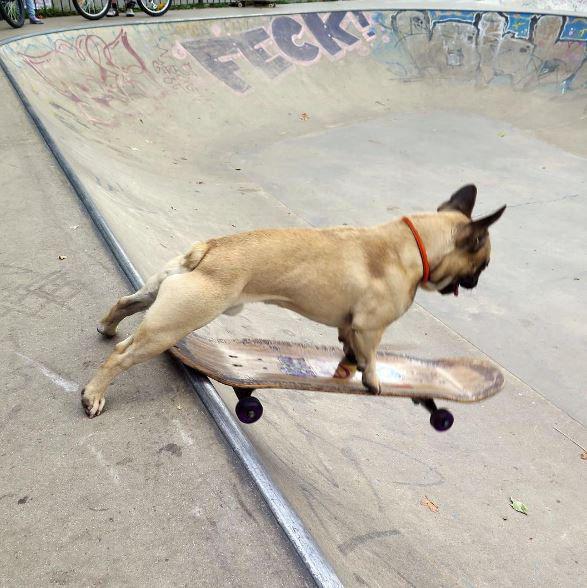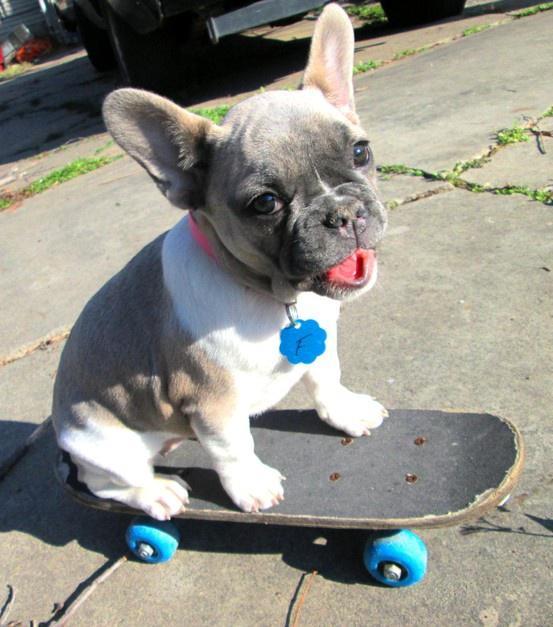The first image is the image on the left, the second image is the image on the right. For the images displayed, is the sentence "At least one image features more than one dog on a skateboard." factually correct? Answer yes or no. No. The first image is the image on the left, the second image is the image on the right. Evaluate the accuracy of this statement regarding the images: "A small dog is perched on a black skateboard with black wheels.". Is it true? Answer yes or no. No. 